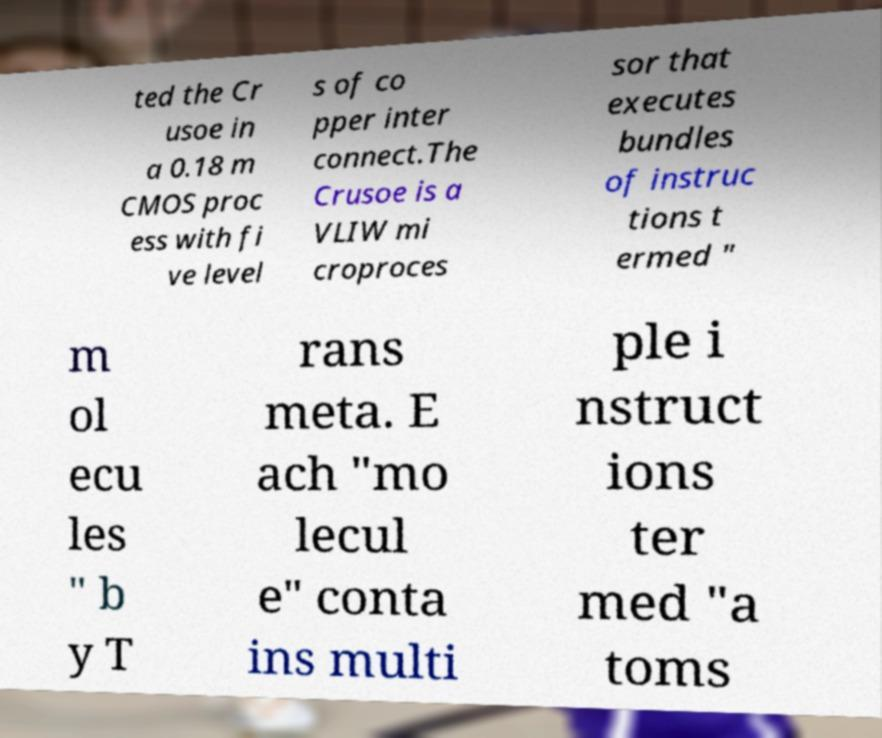There's text embedded in this image that I need extracted. Can you transcribe it verbatim? ted the Cr usoe in a 0.18 m CMOS proc ess with fi ve level s of co pper inter connect.The Crusoe is a VLIW mi croproces sor that executes bundles of instruc tions t ermed " m ol ecu les " b y T rans meta. E ach "mo lecul e" conta ins multi ple i nstruct ions ter med "a toms 